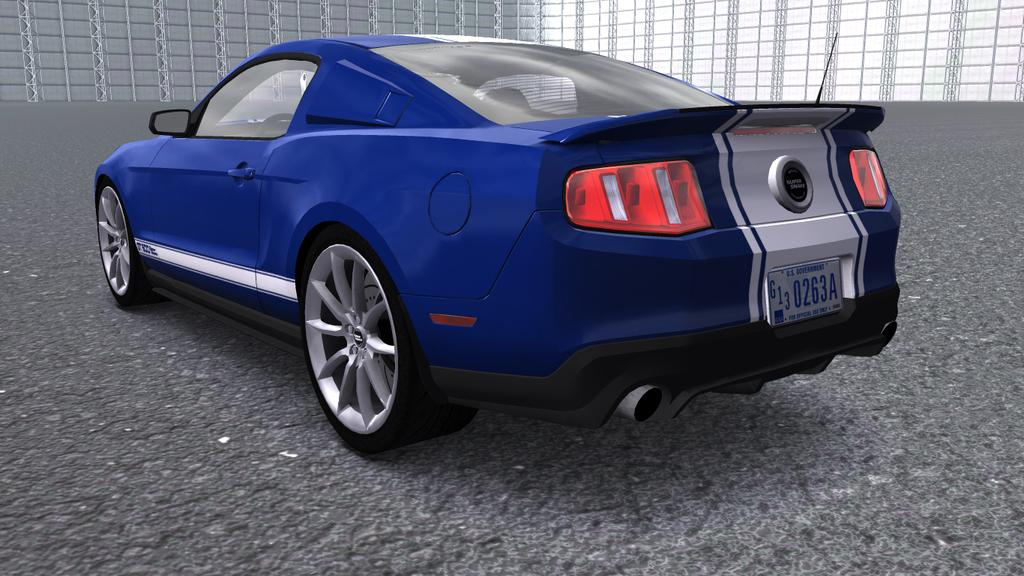What color is the car in the image? The car in the image is blue. Where is the car located in the image? The car is parked on the road. What can be seen in the background of the image? There is a frame wall visible in the background of the image. What type of behavior can be observed in the plate in the image? There is no plate present in the image, so it is not possible to observe any behavior. 